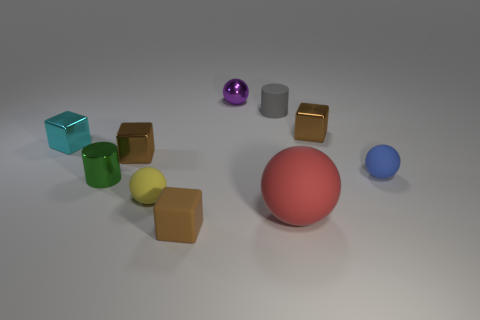There is another small rubber thing that is the same shape as the small blue object; what is its color?
Your answer should be compact. Yellow. Do the small purple ball and the small ball to the left of the small metallic sphere have the same material?
Make the answer very short. No. There is a tiny brown metallic object that is behind the brown shiny block to the left of the small purple shiny ball; what is its shape?
Keep it short and to the point. Cube. There is a brown metal block that is to the left of the purple metallic thing; does it have the same size as the small green shiny object?
Ensure brevity in your answer.  Yes. What number of other objects are there of the same shape as the tiny purple object?
Provide a succinct answer. 3. There is a small metal cube behind the cyan metallic thing; is it the same color as the metal ball?
Make the answer very short. No. Is there a small sphere that has the same color as the large matte ball?
Offer a very short reply. No. What number of green metal things are on the right side of the tiny gray cylinder?
Your response must be concise. 0. How many other objects are there of the same size as the cyan metal thing?
Keep it short and to the point. 8. Is the small brown object that is behind the tiny cyan shiny cube made of the same material as the small object that is behind the tiny gray cylinder?
Your answer should be very brief. Yes. 